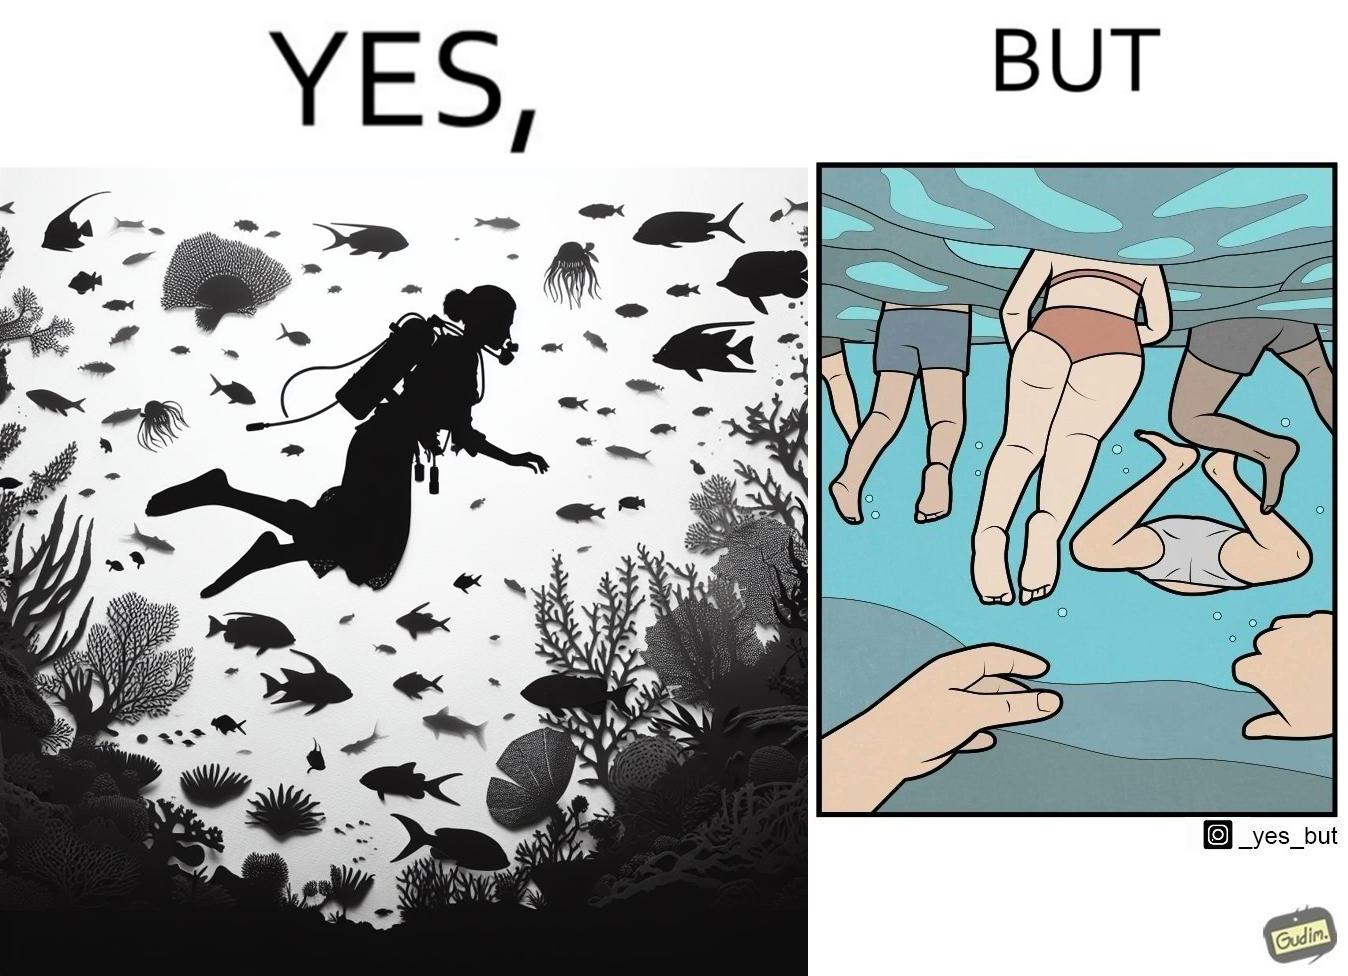Explain the humor or irony in this image. The image is ironic, because some people like to enjoy watching the biodiversity under water but they are not able to explore this due to excess crowd in such places where people like to play, swim etc. in water 